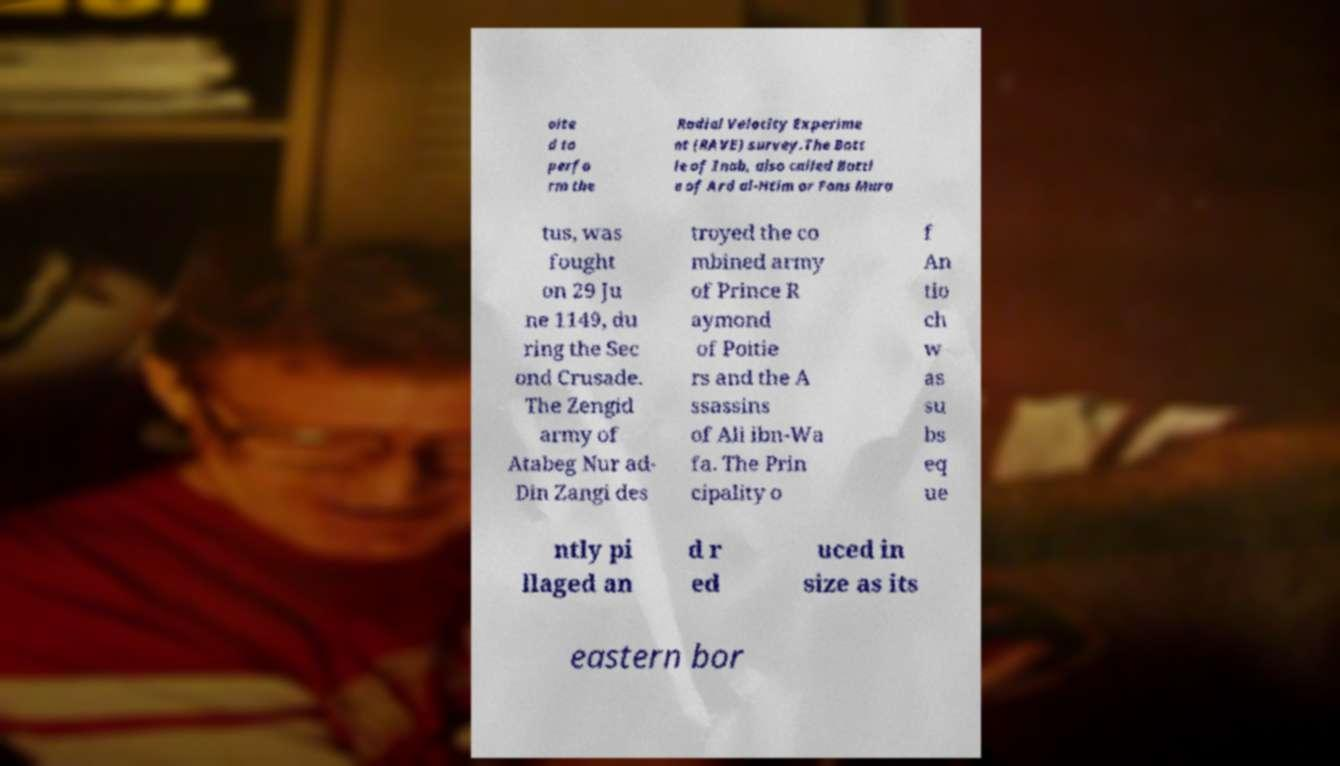I need the written content from this picture converted into text. Can you do that? oite d to perfo rm the Radial Velocity Experime nt (RAVE) survey.The Batt le of Inab, also called Battl e of Ard al-Htim or Fons Mura tus, was fought on 29 Ju ne 1149, du ring the Sec ond Crusade. The Zengid army of Atabeg Nur ad- Din Zangi des troyed the co mbined army of Prince R aymond of Poitie rs and the A ssassins of Ali ibn-Wa fa. The Prin cipality o f An tio ch w as su bs eq ue ntly pi llaged an d r ed uced in size as its eastern bor 